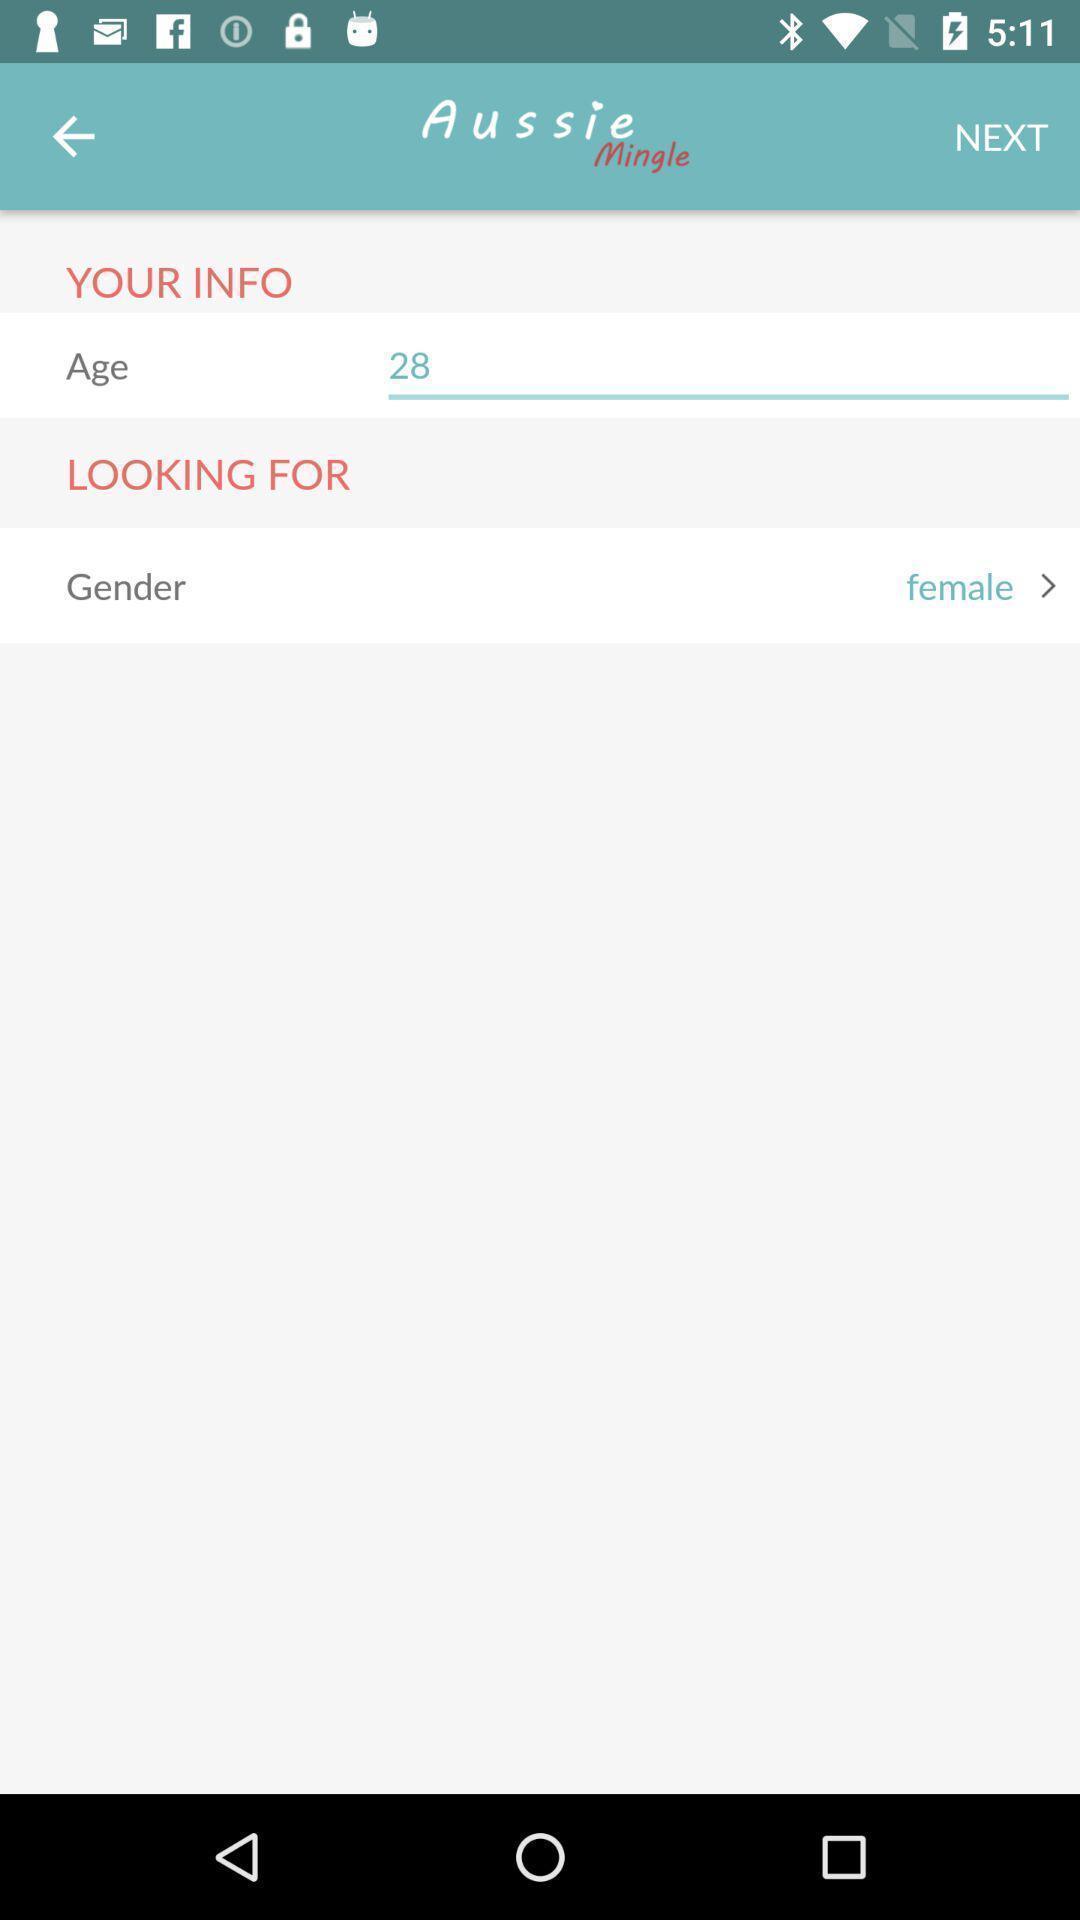Describe the visual elements of this screenshot. Profile editing page of a social app. 